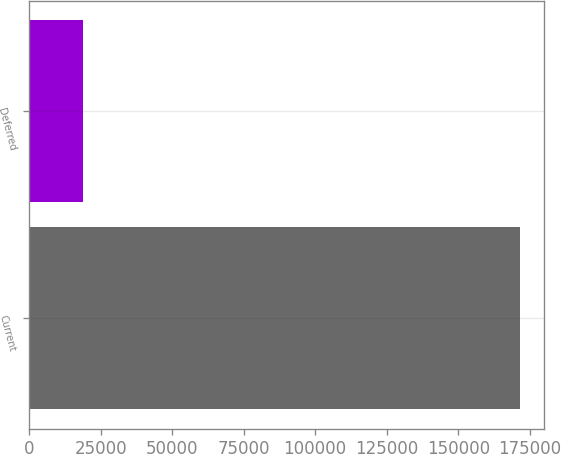Convert chart. <chart><loc_0><loc_0><loc_500><loc_500><bar_chart><fcel>Current<fcel>Deferred<nl><fcel>171507<fcel>18713<nl></chart> 